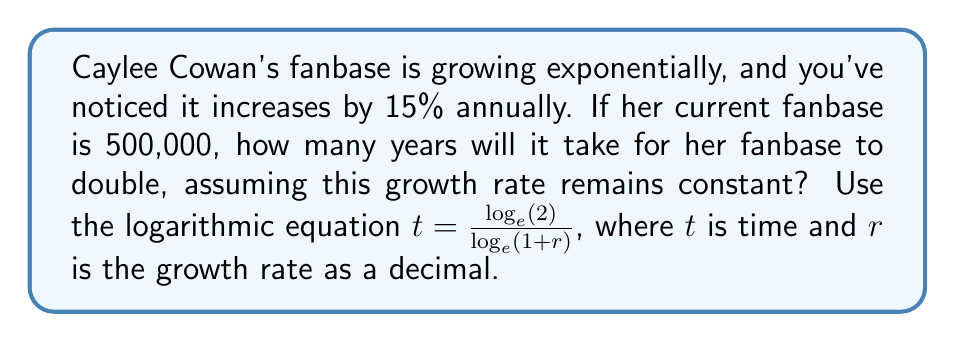Could you help me with this problem? To solve this problem, we'll use the logarithmic equation for doubling time:

$$t = \frac{\log_e(2)}{\log_e(1+r)}$$

Where:
$t$ = time to double
$r$ = growth rate as a decimal

1) First, convert the growth rate to a decimal:
   15% = 0.15

2) Plug the values into the equation:
   $$t = \frac{\log_e(2)}{\log_e(1+0.15)}$$

3) Simplify:
   $$t = \frac{\log_e(2)}{\log_e(1.15)}$$

4) Use a calculator to evaluate:
   $$t \approx \frac{0.6931}{0.1398} \approx 4.96$$

5) Round to the nearest whole year:
   $t \approx 5$ years

Therefore, it will take approximately 5 years for Caylee Cowan's fanbase to double from 500,000 to 1,000,000 at a 15% annual growth rate.
Answer: 5 years 